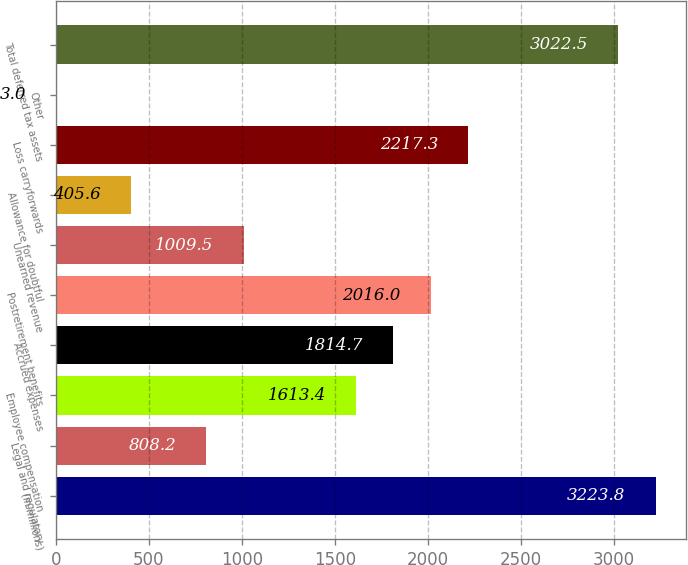Convert chart. <chart><loc_0><loc_0><loc_500><loc_500><bar_chart><fcel>(in millions)<fcel>Legal and regulatory<fcel>Employee compensation<fcel>Accrued expenses<fcel>Postretirement benefits<fcel>Unearned revenue<fcel>Allowance for doubtful<fcel>Loss carryforwards<fcel>Other<fcel>Total deferred tax assets<nl><fcel>3223.8<fcel>808.2<fcel>1613.4<fcel>1814.7<fcel>2016<fcel>1009.5<fcel>405.6<fcel>2217.3<fcel>3<fcel>3022.5<nl></chart> 